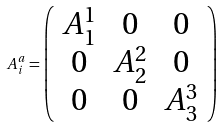<formula> <loc_0><loc_0><loc_500><loc_500>A ^ { a } _ { i } = \left ( \begin{array} { c c c } A ^ { 1 } _ { 1 } & 0 & 0 \\ 0 & A ^ { 2 } _ { 2 } & 0 \\ 0 & 0 & A ^ { 3 } _ { 3 } \\ \end{array} \right )</formula> 